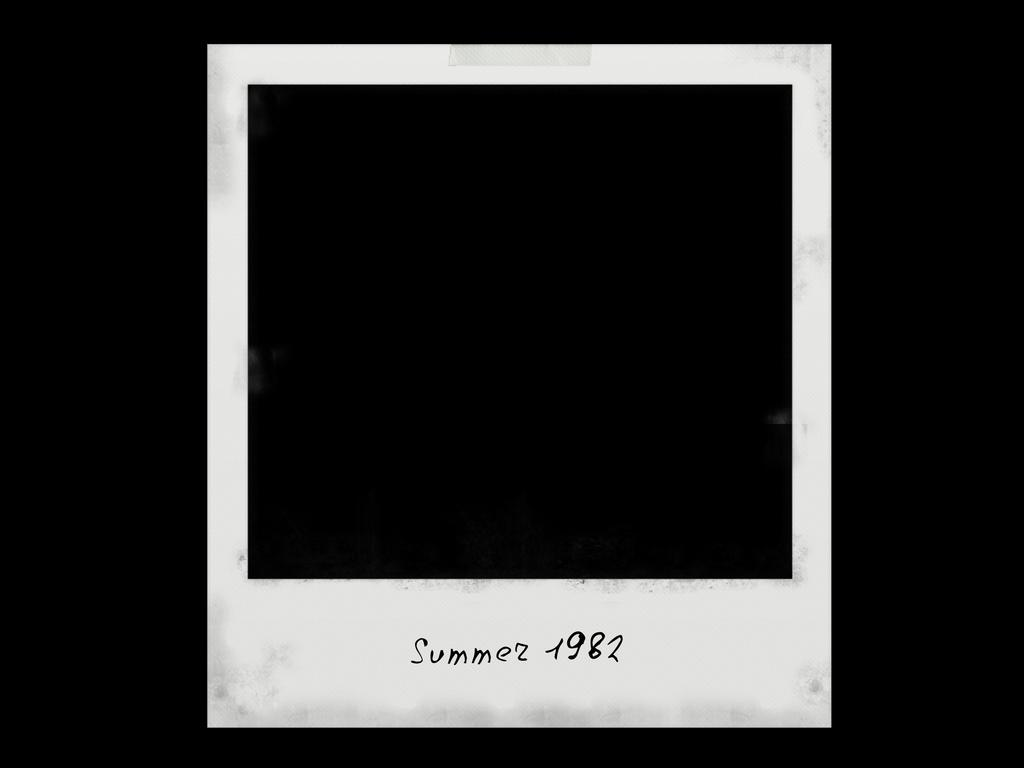Provide a one-sentence caption for the provided image. A completely black Polaroid picture from the summer of 1982. 